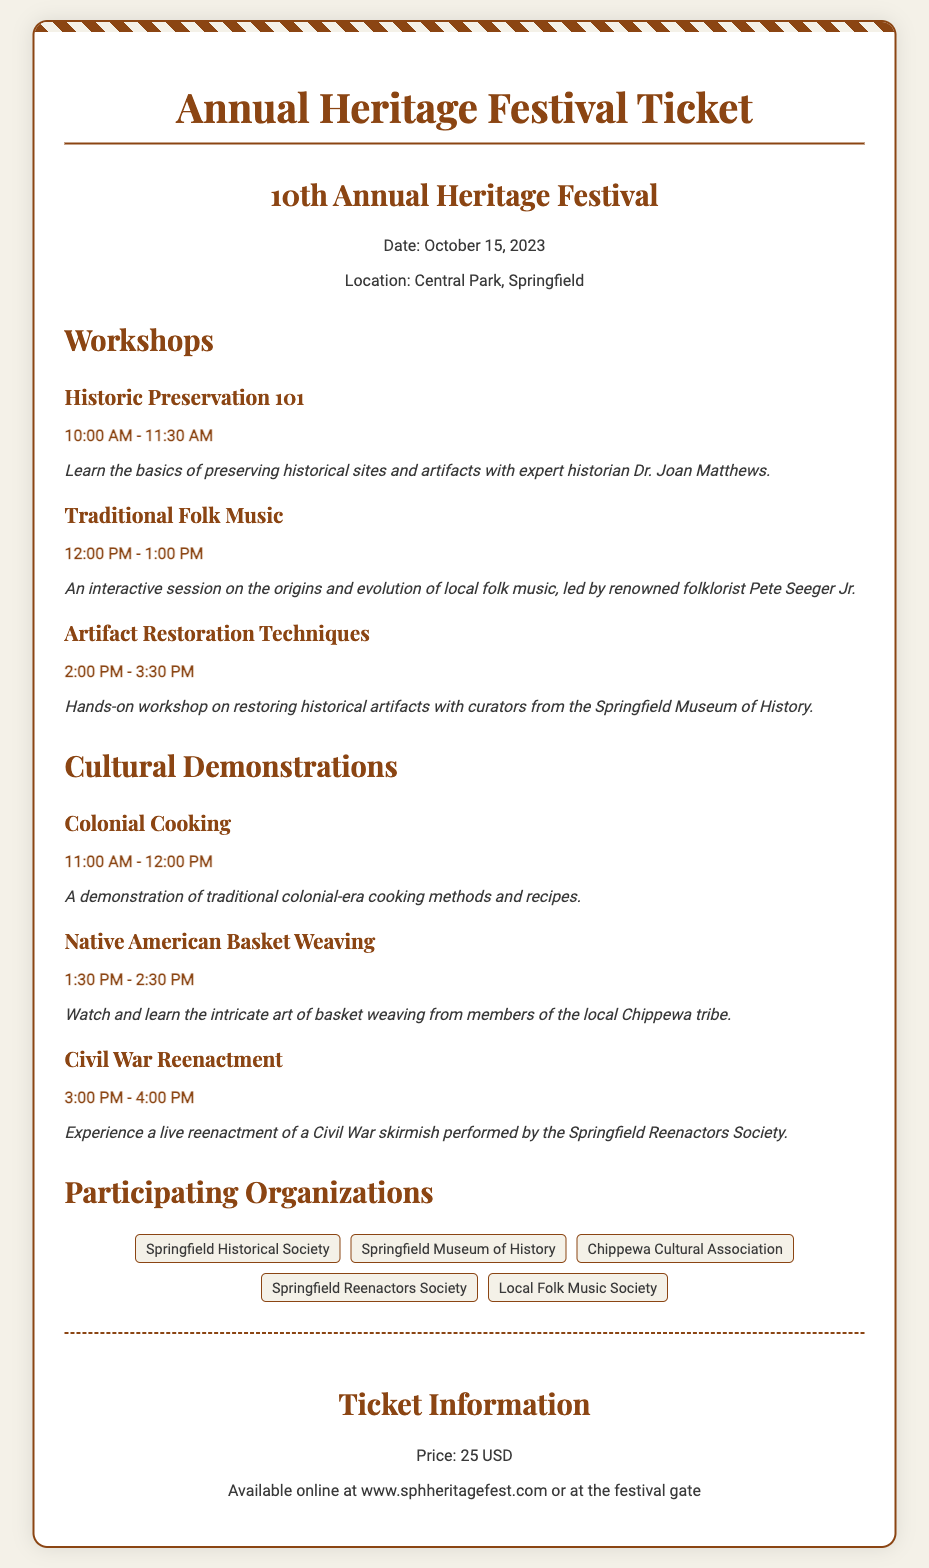what is the date of the festival? The date of the festival is mentioned in the document as October 15, 2023.
Answer: October 15, 2023 where is the festival located? The location of the festival is specified in the document as Central Park, Springfield.
Answer: Central Park, Springfield who is leading the Traditional Folk Music workshop? The document states that the Traditional Folk Music workshop is led by Pete Seeger Jr.
Answer: Pete Seeger Jr what is the price of the ticket? The ticket price is clearly stated in the document as 25 USD.
Answer: 25 USD how many workshops are listed? The document lists three workshops in the Workshops section.
Answer: Three which organization is associated with the Civil War Reenactment demonstration? The document indicates that the Civil War Reenactment is performed by the Springfield Reenactors Society.
Answer: Springfield Reenactors Society what time does the Colonial Cooking demonstration start? The start time for the Colonial Cooking demonstration is mentioned as 11:00 AM.
Answer: 11:00 AM is there a hands-on workshop mentioned in the document? The document includes an Artifact Restoration Techniques workshop, which is a hands-on workshop.
Answer: Yes which organization is not mentioned among the participating organizations? The document does not mention the Springfield Arts Center among the participating organizations.
Answer: Springfield Arts Center 